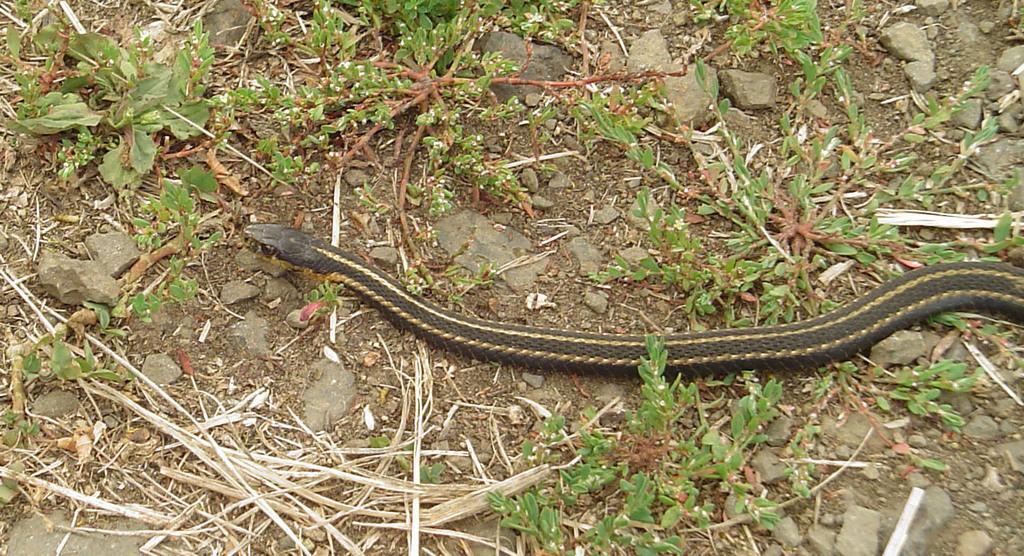In one or two sentences, can you explain what this image depicts? This image consists of a snake in black color. At the bottom, there are small plants and dry grass along with the stones. 